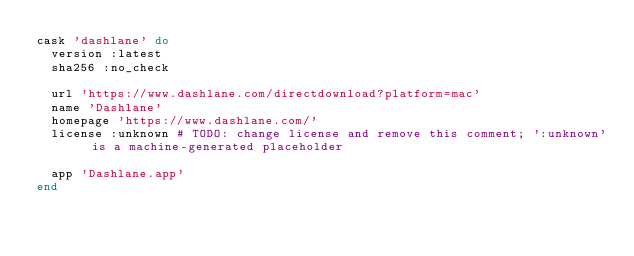Convert code to text. <code><loc_0><loc_0><loc_500><loc_500><_Ruby_>cask 'dashlane' do
  version :latest
  sha256 :no_check

  url 'https://www.dashlane.com/directdownload?platform=mac'
  name 'Dashlane'
  homepage 'https://www.dashlane.com/'
  license :unknown # TODO: change license and remove this comment; ':unknown' is a machine-generated placeholder

  app 'Dashlane.app'
end
</code> 